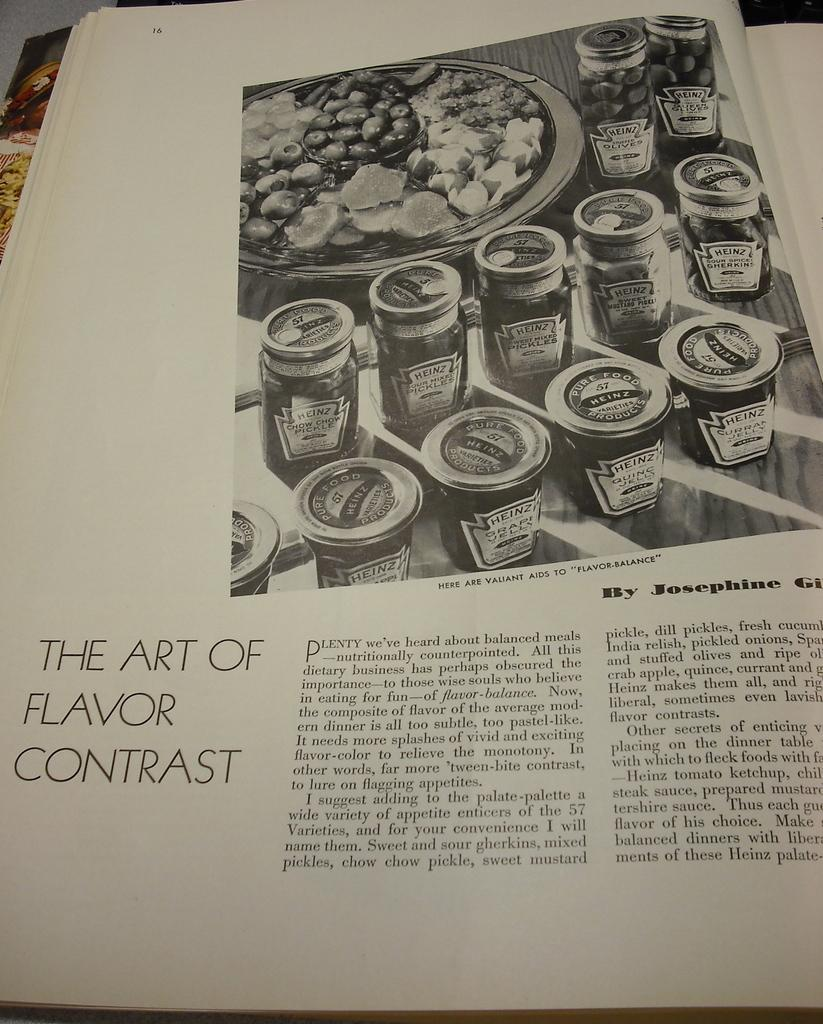<image>
Render a clear and concise summary of the photo. A black and white book page shows jars of Heinz jelly. 